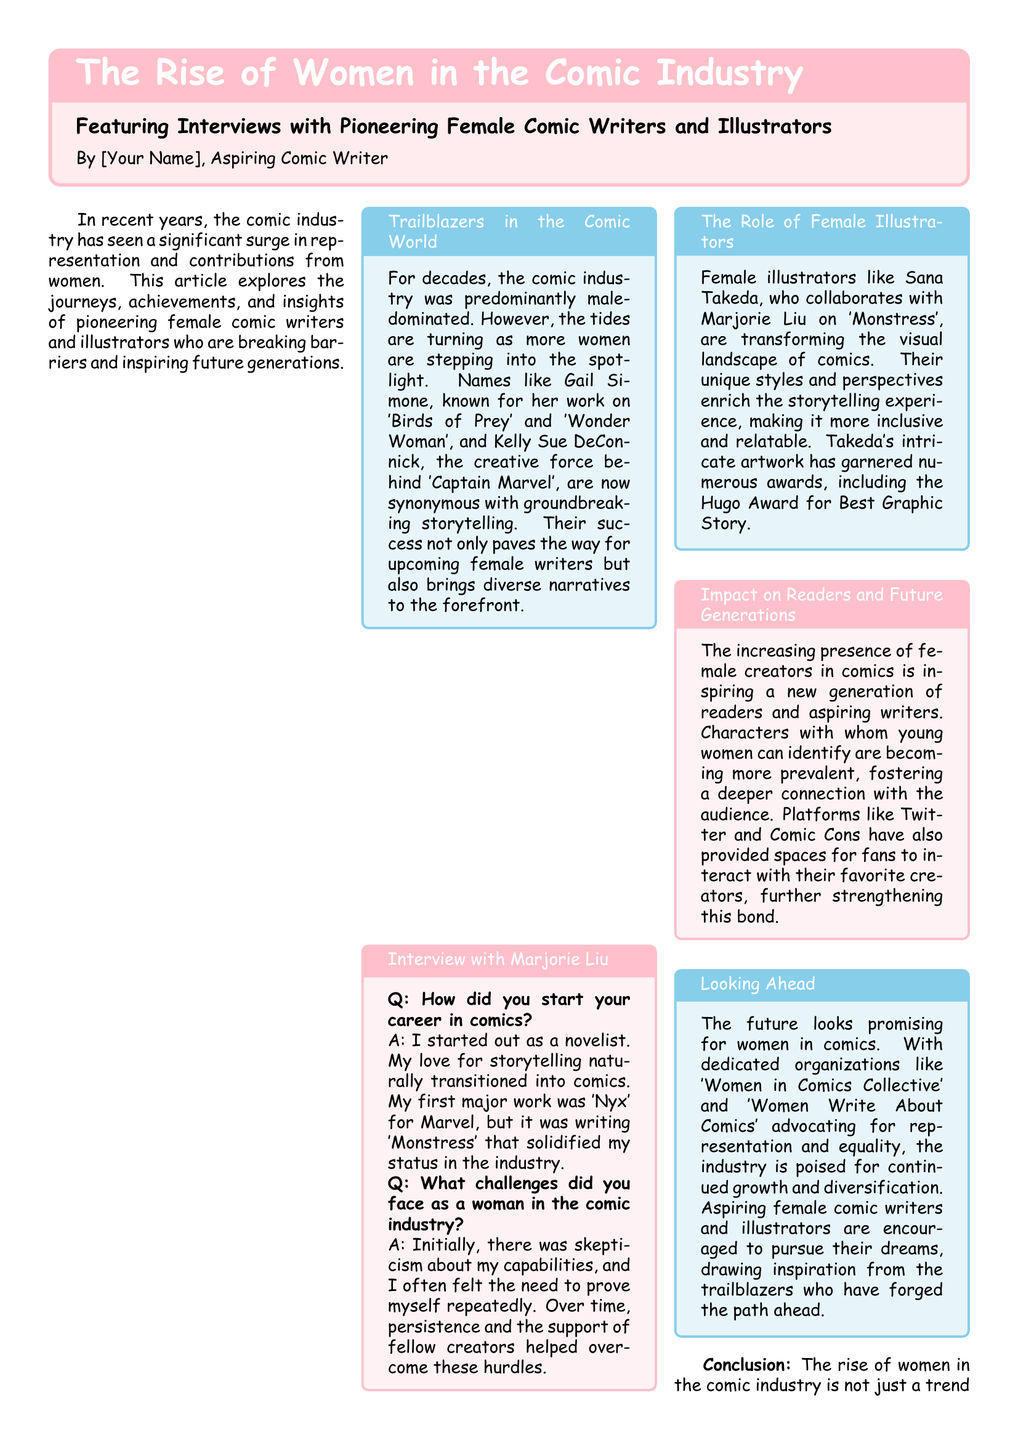What is the title of the article? The title of the article is displayed prominently at the top of the newspaper layout.
Answer: The Rise of Women in the Comic Industry Who is featured in the interviews? The interview section mentions specific female comic writers and illustrators who have made significant contributions to the industry.
Answer: Pioneering Female Comic Writers and Illustrators Which comic did Marjorie Liu first major work on? The document states that her first major work was a specific title for Marvel.
Answer: Nyx What award has Sana Takeda won? The document notes that she has received a prestigious recognition in the comic industry.
Answer: Hugo Award What is the role of the Women in Comics Collective? The document describes organizations that advocate for representation and equality within the comic industry.
Answer: Advocacy for representation and equality How has the presence of female creators impacted young readers? The document discusses the emotional effects and connections that result from increasing female representation in comics.
Answer: Fostering a deeper connection with the audience What genre does this article belong to? The layout and content indicate a specific format focused on current events and cultural discussions.
Answer: Newspaper layout How has female participation changed in the comic industry? The document illustrates a transformation that emphasizes the importance of diversity in storytelling.
Answer: Significant surge in representation Who is known for their work on 'Captain Marvel'? The document mentions a specific female writer who is associated with this popular comic.
Answer: Kelly Sue DeConnick 